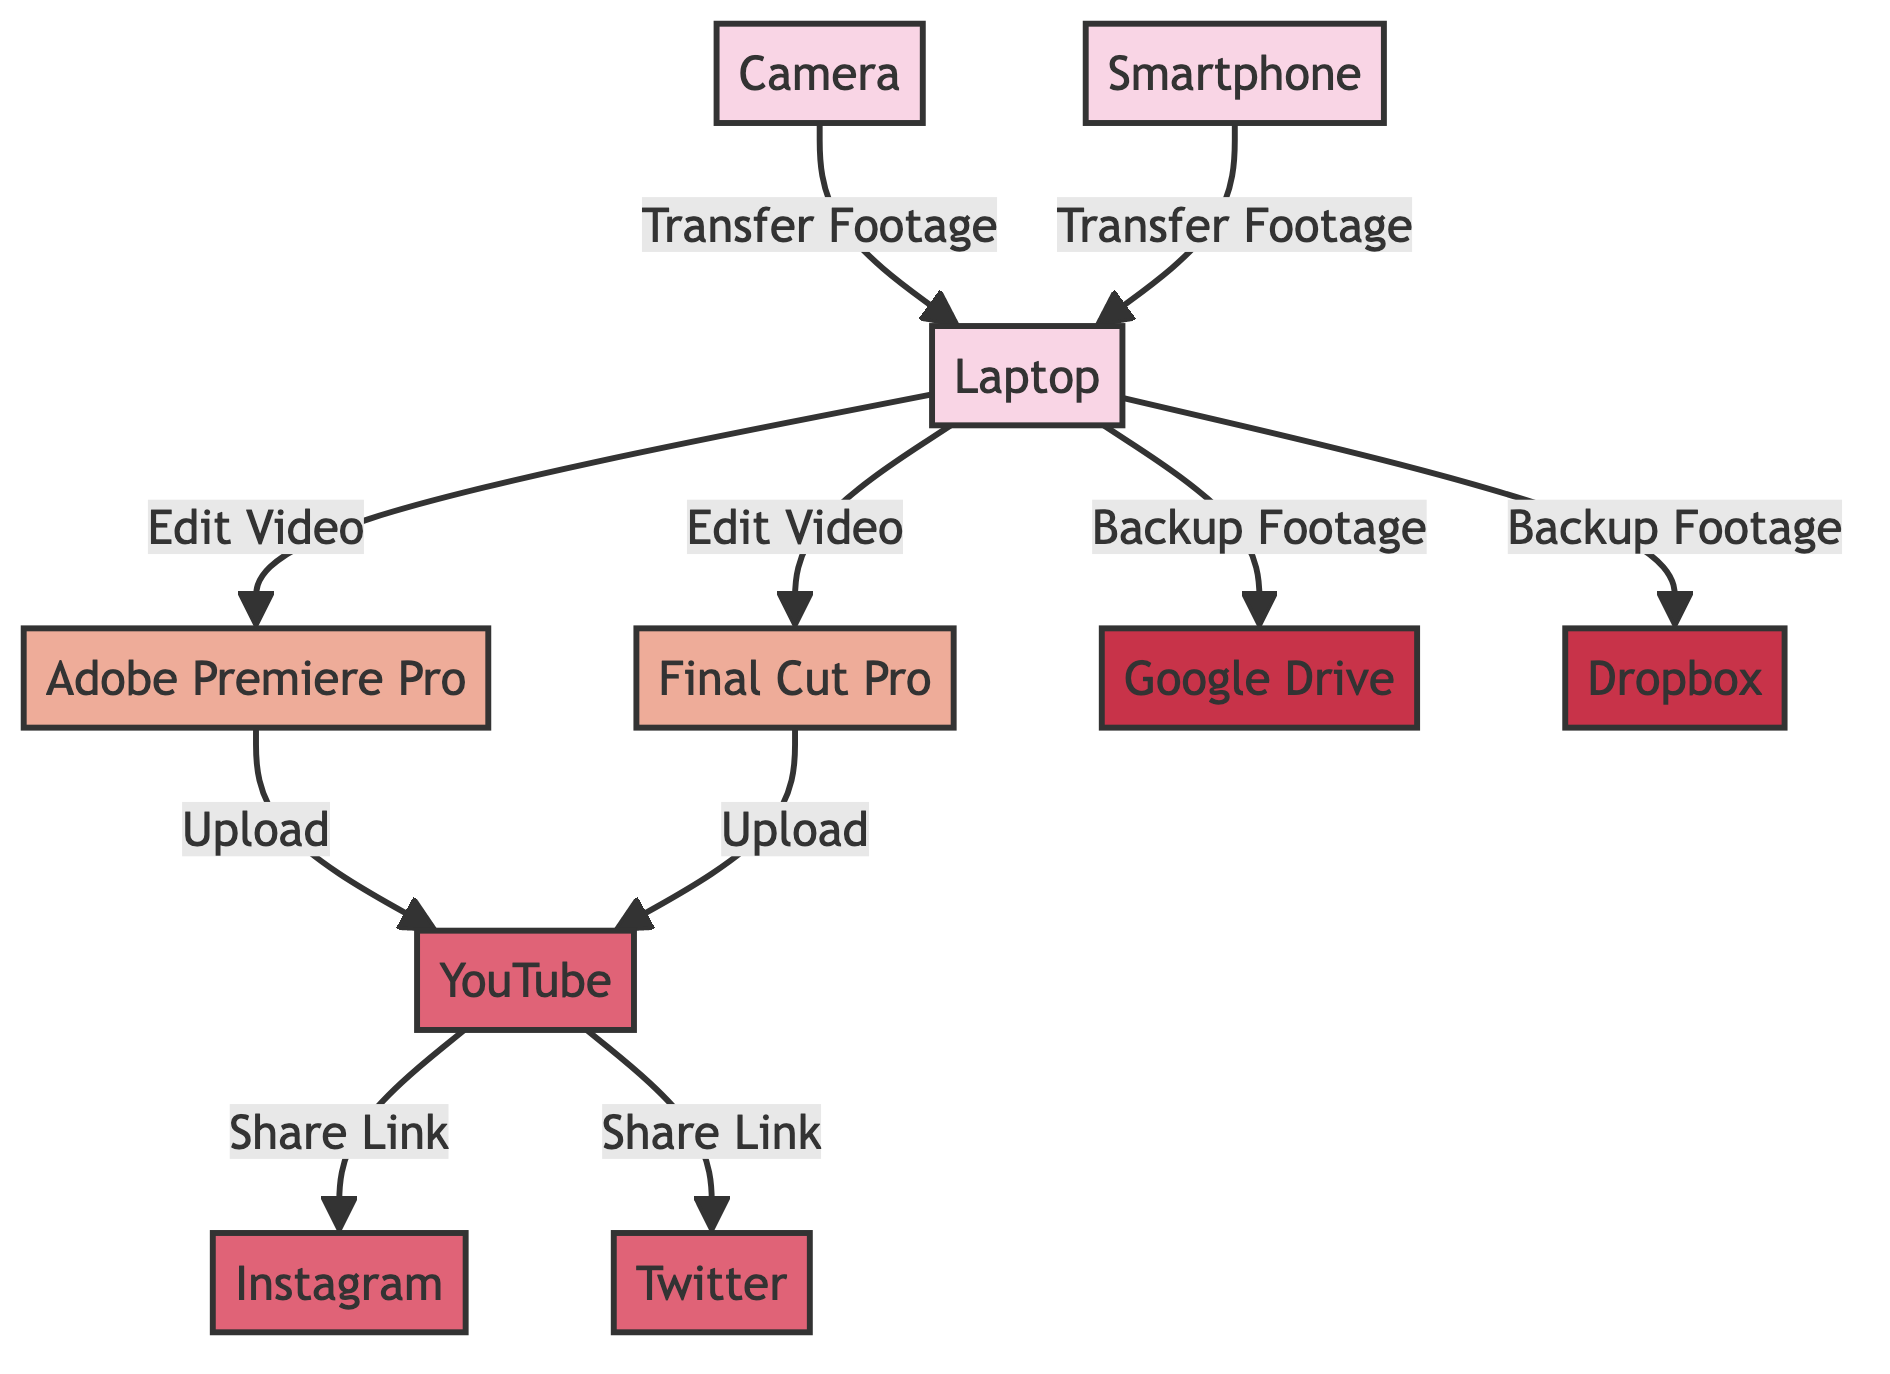What is the total number of nodes in the diagram? The diagram has ten distinct nodes representing various video sources, editing software, sharing platforms, and storage options. Therefore, by counting each unique node listed, we see that there are ten nodes in total.
Answer: 10 Which software is used for video editing in the diagram? The diagram includes two software nodes dedicated to video editing: Adobe Premiere Pro and Final Cut Pro. Therefore, the answer includes both names as they are both used for this purpose.
Answer: Adobe Premiere Pro and Final Cut Pro How many platforms are included in the network? In the diagram, there are three specific nodes that represent platforms where videos can be shared: YouTube, Instagram, and Twitter. By counting these platform nodes, we establish that there are three platforms in total.
Answer: 3 What is the common function between the Camera and Smartphone in the diagram? Both the Camera and Smartphone nodes in the diagram are connected to the Laptop node with the same label of the relationship, which is "Transfer Footage." This indicates that the common function between these two sources is that they both enable the transfer of video footage to the laptop.
Answer: Transfer Footage Which nodes are connected to the Laptop for backing up footage? The diagram shows that the Laptop node connects to both Google Drive and Dropbox with the relationship labeled as "Backup Footage." Therefore, the nodes that serve as backup options for footage are Google Drive and Dropbox.
Answer: Google Drive and Dropbox How many edges represent the uploading of videos in the diagram? The diagram shows connections from both editing software nodes (Adobe Premiere Pro and Final Cut Pro) to the YouTube platform, each representing an upload action. By identifying the edges labeled "Upload," we find there are two such edges present in the diagram.
Answer: 2 What are the pathways leading to the Instagram node? To reach the Instagram node, one must follow the edge from the YouTube node, as there are no direct connections to this platform from other nodes. The pathway illustrates that the Instagram node can only be accessed by sharing a link from YouTube.
Answer: YouTube Which two nodes have the editing relationship with the Laptop? The Laptop node connects to both Adobe Premiere Pro and Final Cut Pro with the edges labeled as "Edit Video." Thus, both of these software options share a relationship with the Laptop specifically for video editing purposes.
Answer: Adobe Premiere Pro and Final Cut Pro What action connects the YouTube node to the Twitter node? The connection between the YouTube node and the Twitter node is described by the edge labeled "Share Link." Hence, the specific action that links these two nodes is sharing a link that points from YouTube to Twitter.
Answer: Share Link 